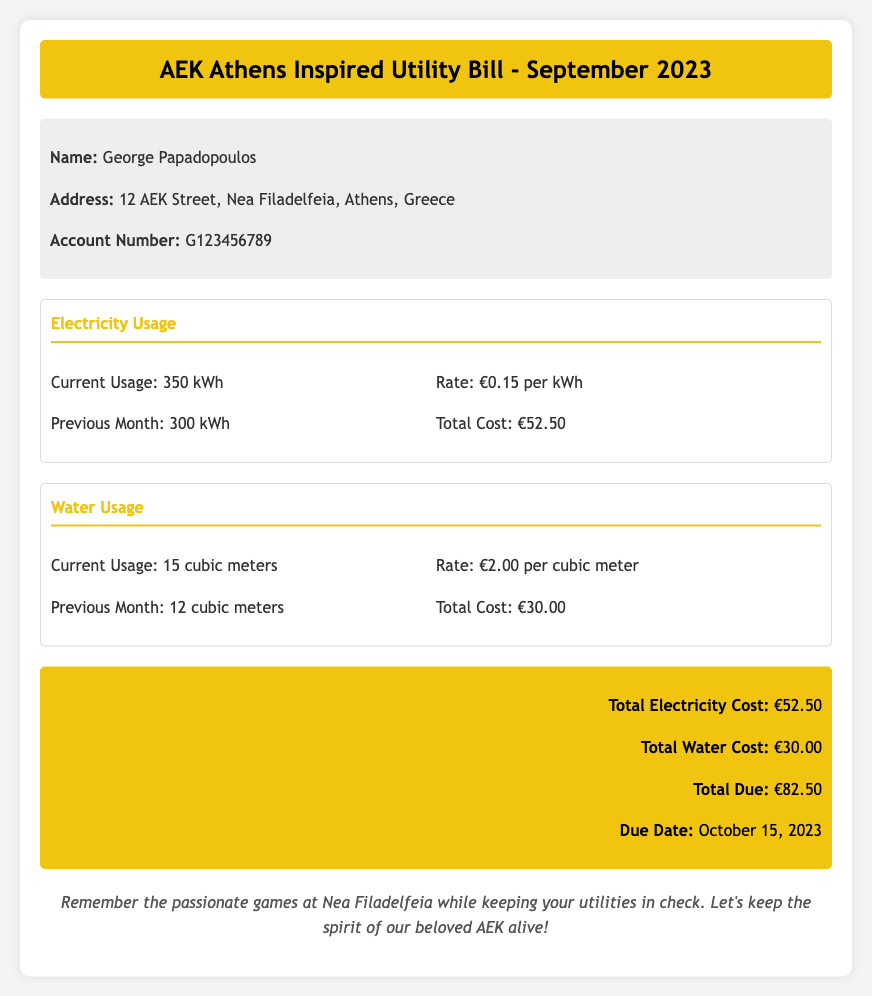What is the name of the account holder? The account holder's name is George Papadopoulos, as stated in the customer info section.
Answer: George Papadopoulos What is the current electricity usage? The current electricity usage is explicitly mentioned in the usage section for electricity.
Answer: 350 kWh What is the rate per cubic meter of water? The rate for water usage can be found in the usage section for water.
Answer: €2.00 per cubic meter What was the previous month's electricity usage? The previous month's electricity usage is compared to the current usage in the electricity section.
Answer: 300 kWh What is the total due amount? The total due amount is calculated from the total costs for electricity and water.
Answer: €82.50 What is the due date for the bill? The due date is specified in the summary section of the bill.
Answer: October 15, 2023 What was the total cost of electricity usage? The total cost of electricity is provided in the summary section after calculating the current usage by rate.
Answer: €52.50 How much did water usage increase from the previous month? The increase in water usage is derived from the current and previous month usage figures.
Answer: 3 cubic meters What is the background color of the header? The header section has a defined background color mentioned in the styling of the document.
Answer: #F1C40F 